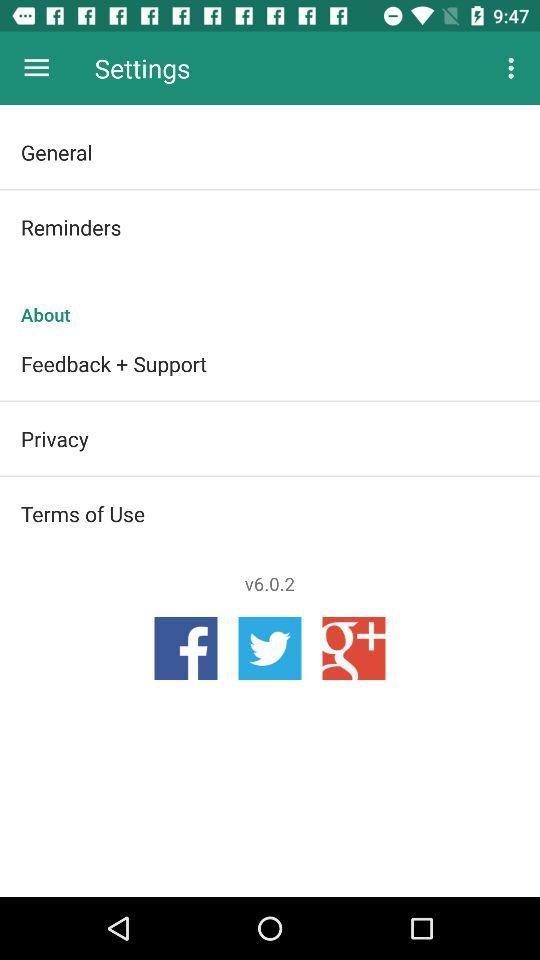What is the version? The version is 6.0.2. 